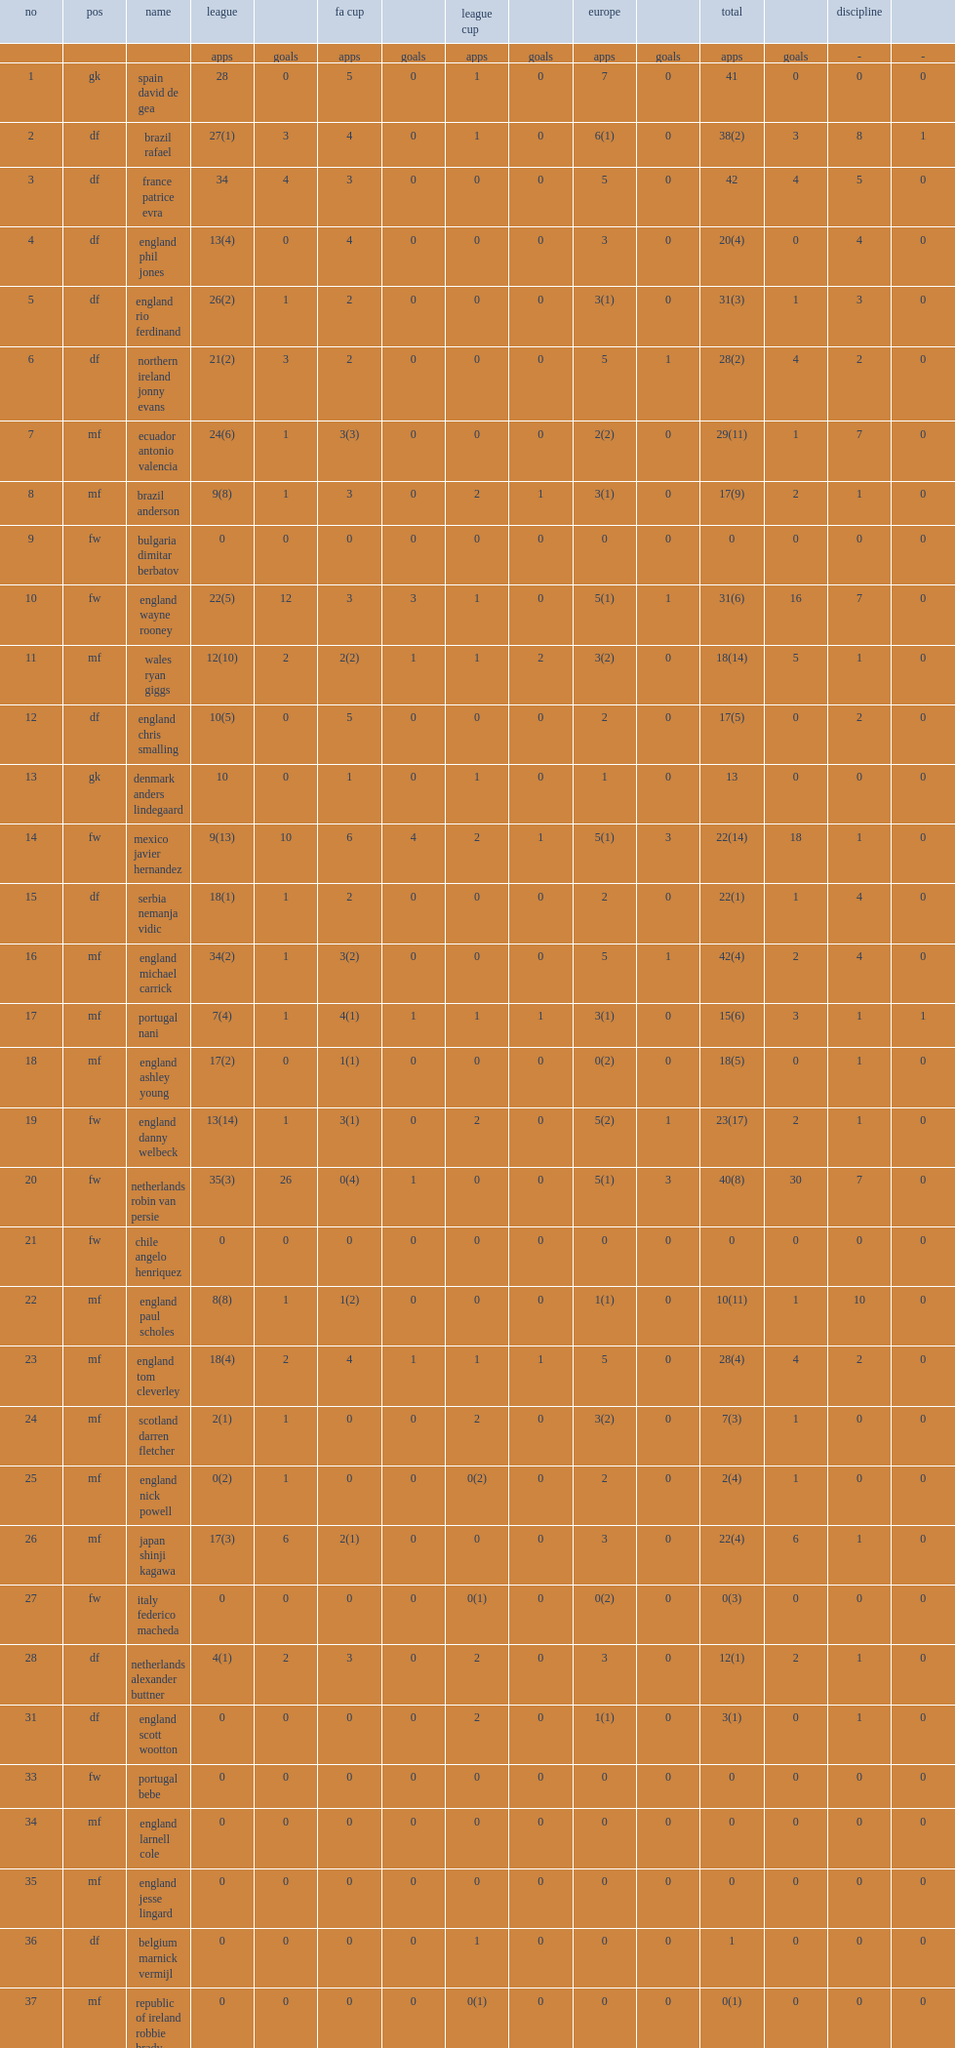Could you parse the entire table as a dict? {'header': ['no', 'pos', 'name', 'league', '', 'fa cup', '', 'league cup', '', 'europe', '', 'total', '', 'discipline', ''], 'rows': [['', '', '', 'apps', 'goals', 'apps', 'goals', 'apps', 'goals', 'apps', 'goals', 'apps', 'goals', '-', '-'], ['1', 'gk', 'spain david de gea', '28', '0', '5', '0', '1', '0', '7', '0', '41', '0', '0', '0'], ['2', 'df', 'brazil rafael', '27(1)', '3', '4', '0', '1', '0', '6(1)', '0', '38(2)', '3', '8', '1'], ['3', 'df', 'france patrice evra', '34', '4', '3', '0', '0', '0', '5', '0', '42', '4', '5', '0'], ['4', 'df', 'england phil jones', '13(4)', '0', '4', '0', '0', '0', '3', '0', '20(4)', '0', '4', '0'], ['5', 'df', 'england rio ferdinand', '26(2)', '1', '2', '0', '0', '0', '3(1)', '0', '31(3)', '1', '3', '0'], ['6', 'df', 'northern ireland jonny evans', '21(2)', '3', '2', '0', '0', '0', '5', '1', '28(2)', '4', '2', '0'], ['7', 'mf', 'ecuador antonio valencia', '24(6)', '1', '3(3)', '0', '0', '0', '2(2)', '0', '29(11)', '1', '7', '0'], ['8', 'mf', 'brazil anderson', '9(8)', '1', '3', '0', '2', '1', '3(1)', '0', '17(9)', '2', '1', '0'], ['9', 'fw', 'bulgaria dimitar berbatov', '0', '0', '0', '0', '0', '0', '0', '0', '0', '0', '0', '0'], ['10', 'fw', 'england wayne rooney', '22(5)', '12', '3', '3', '1', '0', '5(1)', '1', '31(6)', '16', '7', '0'], ['11', 'mf', 'wales ryan giggs', '12(10)', '2', '2(2)', '1', '1', '2', '3(2)', '0', '18(14)', '5', '1', '0'], ['12', 'df', 'england chris smalling', '10(5)', '0', '5', '0', '0', '0', '2', '0', '17(5)', '0', '2', '0'], ['13', 'gk', 'denmark anders lindegaard', '10', '0', '1', '0', '1', '0', '1', '0', '13', '0', '0', '0'], ['14', 'fw', 'mexico javier hernandez', '9(13)', '10', '6', '4', '2', '1', '5(1)', '3', '22(14)', '18', '1', '0'], ['15', 'df', 'serbia nemanja vidic', '18(1)', '1', '2', '0', '0', '0', '2', '0', '22(1)', '1', '4', '0'], ['16', 'mf', 'england michael carrick', '34(2)', '1', '3(2)', '0', '0', '0', '5', '1', '42(4)', '2', '4', '0'], ['17', 'mf', 'portugal nani', '7(4)', '1', '4(1)', '1', '1', '1', '3(1)', '0', '15(6)', '3', '1', '1'], ['18', 'mf', 'england ashley young', '17(2)', '0', '1(1)', '0', '0', '0', '0(2)', '0', '18(5)', '0', '1', '0'], ['19', 'fw', 'england danny welbeck', '13(14)', '1', '3(1)', '0', '2', '0', '5(2)', '1', '23(17)', '2', '1', '0'], ['20', 'fw', 'netherlands robin van persie', '35(3)', '26', '0(4)', '1', '0', '0', '5(1)', '3', '40(8)', '30', '7', '0'], ['21', 'fw', 'chile angelo henriquez', '0', '0', '0', '0', '0', '0', '0', '0', '0', '0', '0', '0'], ['22', 'mf', 'england paul scholes', '8(8)', '1', '1(2)', '0', '0', '0', '1(1)', '0', '10(11)', '1', '10', '0'], ['23', 'mf', 'england tom cleverley', '18(4)', '2', '4', '1', '1', '1', '5', '0', '28(4)', '4', '2', '0'], ['24', 'mf', 'scotland darren fletcher', '2(1)', '1', '0', '0', '2', '0', '3(2)', '0', '7(3)', '1', '0', '0'], ['25', 'mf', 'england nick powell', '0(2)', '1', '0', '0', '0(2)', '0', '2', '0', '2(4)', '1', '0', '0'], ['26', 'mf', 'japan shinji kagawa', '17(3)', '6', '2(1)', '0', '0', '0', '3', '0', '22(4)', '6', '1', '0'], ['27', 'fw', 'italy federico macheda', '0', '0', '0', '0', '0(1)', '0', '0(2)', '0', '0(3)', '0', '0', '0'], ['28', 'df', 'netherlands alexander buttner', '4(1)', '2', '3', '0', '2', '0', '3', '0', '12(1)', '2', '1', '0'], ['31', 'df', 'england scott wootton', '0', '0', '0', '0', '2', '0', '1(1)', '0', '3(1)', '0', '1', '0'], ['33', 'fw', 'portugal bebe', '0', '0', '0', '0', '0', '0', '0', '0', '0', '0', '0', '0'], ['34', 'mf', 'england larnell cole', '0', '0', '0', '0', '0', '0', '0', '0', '0', '0', '0', '0'], ['35', 'mf', 'england jesse lingard', '0', '0', '0', '0', '0', '0', '0', '0', '0', '0', '0', '0'], ['36', 'df', 'belgium marnick vermijl', '0', '0', '0', '0', '1', '0', '0', '0', '1', '0', '0', '0'], ['37', 'mf', 'republic of ireland robbie brady', '0', '0', '0', '0', '0(1)', '0', '0', '0', '0(1)', '0', '0', '0'], ['38', 'df', 'england michael keane', '0', '0', '0', '0', '2', '0', '0', '0', '2', '0', '1', '0'], ['39', 'df', 'england tom thorpe', '0', '0', '0', '0', '0', '0', '0', '0', '0', '0', '0', '0'], ['40', 'gk', 'england ben amos', '0', '0', '0', '0', '0', '0', '0', '0', '0', '0', '0', '0'], ['41', 'fw', 'norway joshua king', '0', '0', '0', '0', '0', '0', '0(1)', '0', '0(1)', '0', '0', '0'], ['42', 'df', 'england tyler blackett', '0', '0', '0', '0', '0', '0', '0', '0', '0', '0', '0', '0'], ['44', 'mf', 'belgium adnan januzaj', '0', '0', '0', '0', '0', '0', '0', '0', '0', '0', '0', '0'], ['45', 'mf', 'italy davide petrucci', '0', '0', '0', '0', '0', '0', '0', '0', '0', '0', '0', '0'], ['46', 'mf', 'england ryan tunnicliffe', '0', '0', '0', '0', '0(2)', '0', '0', '0', '0(2)', '0', '0', '0'], ['48', 'fw', 'england will keane', '0', '0', '0', '0', '0', '0', '0', '0', '0', '0', '0', '0'], ['49', 'df', 'switzerland freddie veseli', '0', '0', '0', '0', '0', '0', '0', '0', '0', '0', '0', '0'], ['50', 'gk', 'england sam johnstone', '0', '0', '0', '0', '0', '0', '0', '0', '0', '0', '0', '0'], ['-', 'df', 'brazil fabio', '0', '0', '0', '0', '0', '0', '0', '0', '0', '0', '0', '0'], ['-', 'fw', 'england wilfried zaha', '0', '0', '0', '0', '0', '0', '0', '0', '0', '0', '0', '0'], ['-', '-', 'own goals', '-', '6', '-', '0', '-', '0', '-', '1', '-', '7', '-', '-']]} What cups did united play for? Fa cup league cup. 